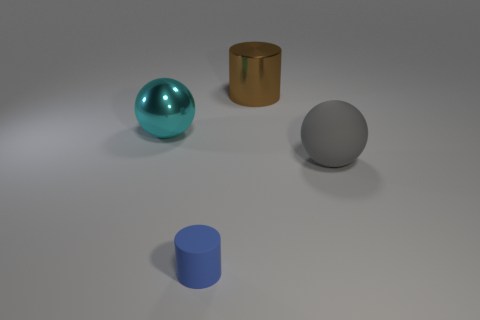Is there anything else that is the same size as the blue cylinder?
Keep it short and to the point. No. What is the material of the big cylinder?
Your answer should be very brief. Metal. Is the object behind the large cyan metallic thing made of the same material as the blue cylinder?
Your answer should be very brief. No. What is the shape of the large shiny object that is to the right of the tiny object?
Your response must be concise. Cylinder. What is the material of the brown thing that is the same size as the cyan thing?
Your answer should be compact. Metal. How many things are rubber things that are to the right of the metallic cylinder or big balls that are to the left of the tiny rubber object?
Offer a very short reply. 2. There is a brown thing that is made of the same material as the large cyan object; what is its size?
Offer a very short reply. Large. What number of shiny things are large objects or small purple cylinders?
Make the answer very short. 2. The blue rubber thing is what size?
Ensure brevity in your answer.  Small. Does the matte ball have the same size as the cyan ball?
Your response must be concise. Yes. 